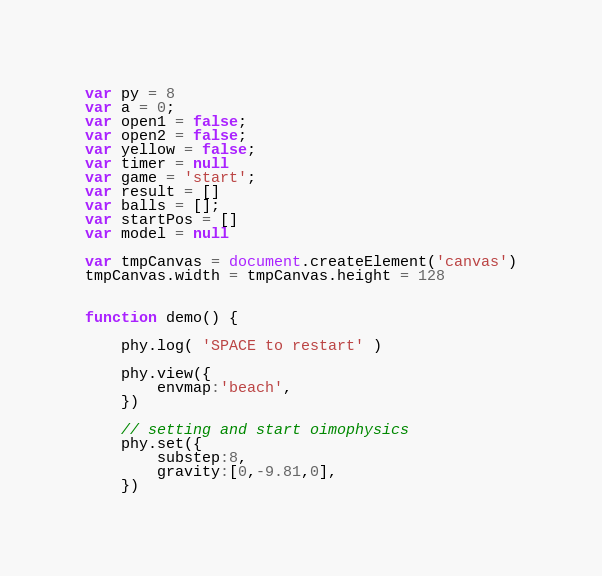<code> <loc_0><loc_0><loc_500><loc_500><_JavaScript_>
var py = 8
var a = 0;
var open1 = false;
var open2 = false;
var yellow = false;
var timer = null
var game = 'start';
var result = []
var balls = [];
var startPos = []
var model = null

var tmpCanvas = document.createElement('canvas')
tmpCanvas.width = tmpCanvas.height = 128


function demo() {

    phy.log( 'SPACE to restart' )

	phy.view({
		envmap:'beach',
	})

	// setting and start oimophysics
	phy.set({ 
		substep:8,
		gravity:[0,-9.81,0],
	})
</code> 